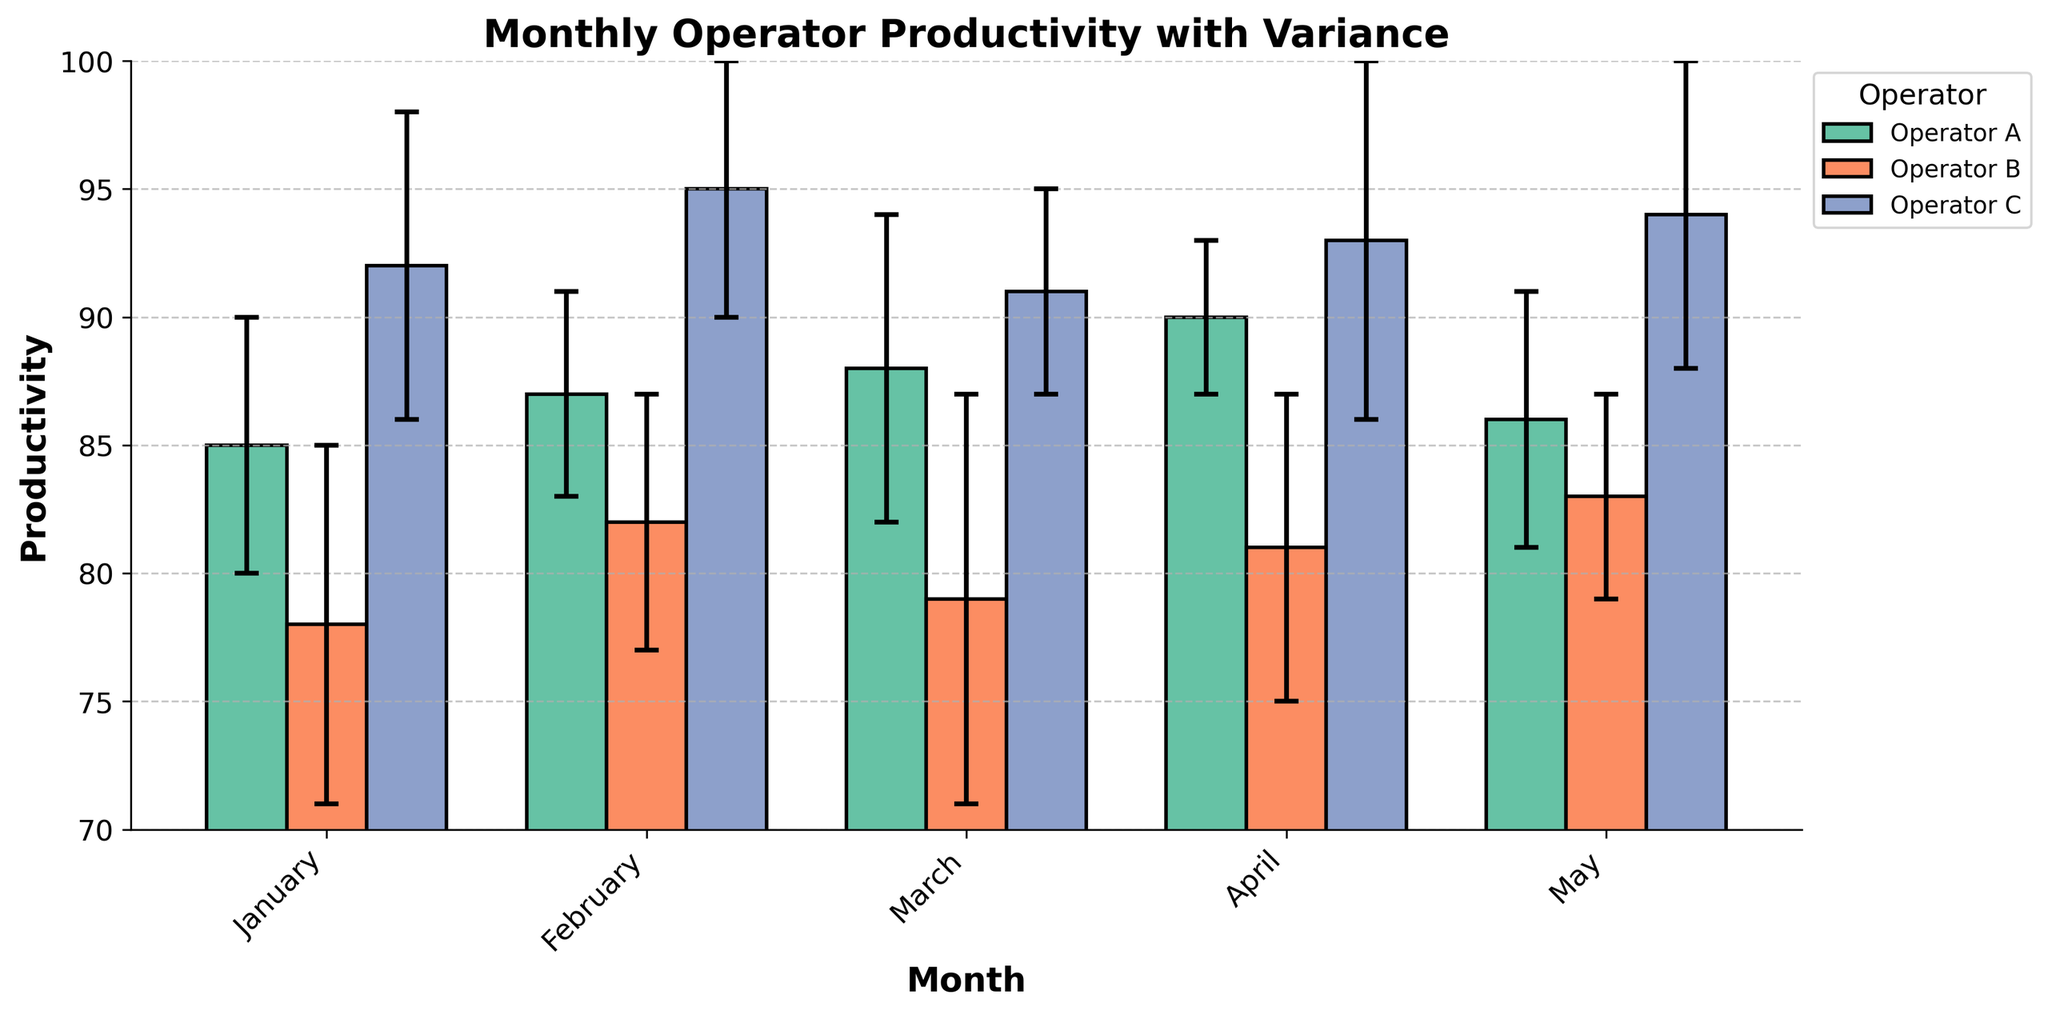Which month shows the highest productivity for Operator C? In the figure, locate the bars representing Operator C for each month. Identify the highest bar, which visually represents the highest productivity. The month with this highest bar is the answer.
Answer: February What is the title of the figure? Look at the top part of the figure where the title is usually placed, which is "Monthly Operator Productivity with Variance."
Answer: Monthly Operator Productivity with Variance What is the average productivity of Operator A across all months? Find the bar heights corresponding to Operator A across all months: January (85), February (87), March (88), April (90), May (86). Calculate the average of these values: (85 + 87 + 88 + 90 + 86) / 5 = 87.2
Answer: 87.2 In March, how does the productivity of Operator B compare to that of Operator C? For March, locate the productivity bars for Operator B and Operator C. Compare the heights of these two bars. Operator B has a productivity of 79, and Operator C has a productivity of 91. Therefore, Operator B's productivity is lower than Operator C's in March.
Answer: Lower Which month has the smallest variance in Operator A's productivity? Identify the error bars (representing standard deviation) for Operator A across all months. Look for the shortest error bar. In April, the standard deviation is 3, which is the smallest.
Answer: April How does the productivity of Operator B in February compare to Operator A in April? Find the productivity of Operator B in February (82) and of Operator A in April (90). Compare these two values; Operator A in April is much higher.
Answer: Much higher Which operator shows the most consistent productivity based on the smallest average standard deviation? Calculate the average standard deviation for each operator. Operator A: (5 + 4 + 6 + 3 + 5) / 5 = 4.6, Operator B: (7 + 5 + 8 + 6 + 4) / 5 = 6, Operator C: (6 + 5 + 4 + 7 + 6) / 5 = 5.6. Operator A has the smallest average standard deviation.
Answer: Operator A In which month is the gap between the productivity of Operator A and Operator B the largest? Calculate the absolute differences in productivity between Operator A and Operator B for each month: January (85-78=7), February (87-82=5), March (88-79=9), April (90-81=9), May (86-83=3). March and April have the largest gap of 9.
Answer: March and April 